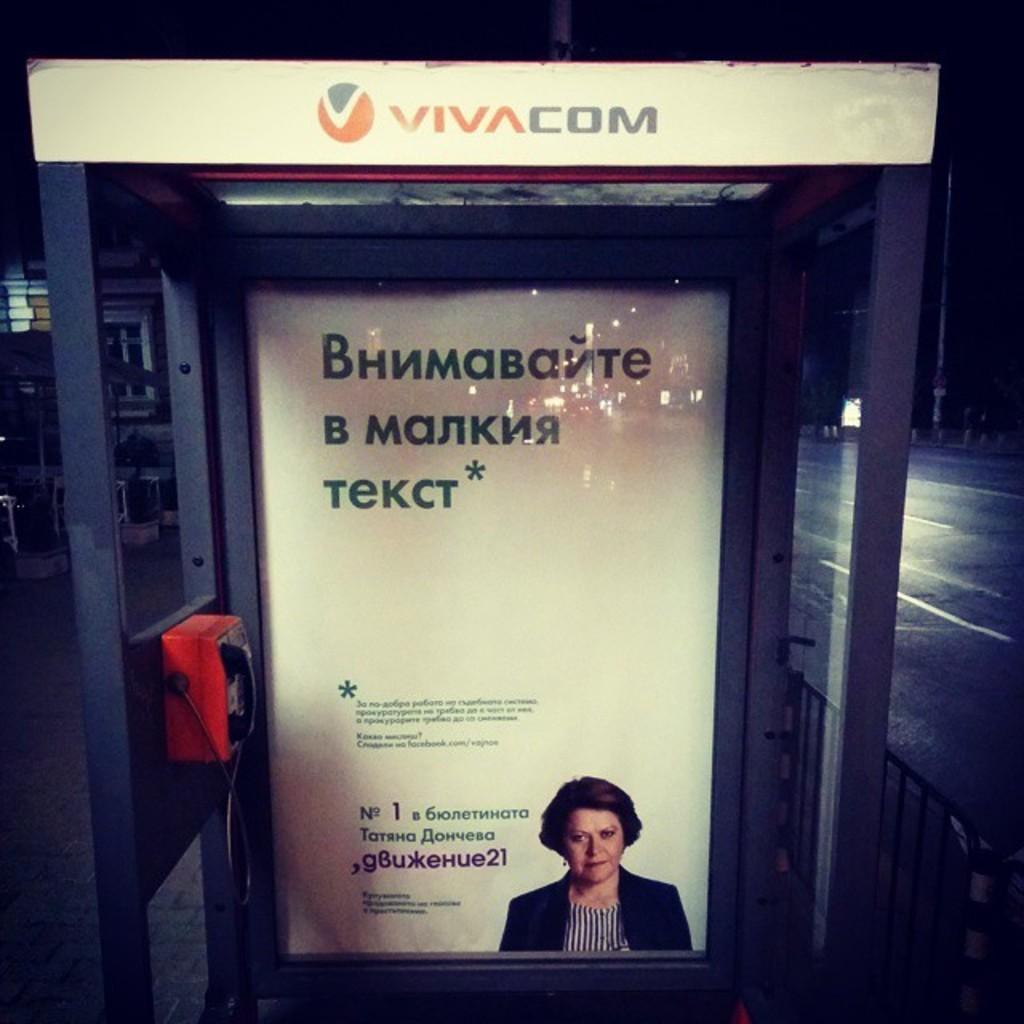Please provide a concise description of this image. There is a telephone booth. There is a red telephone at the left side and a poster at the back. There is a fencing, road and a pole at the right. 